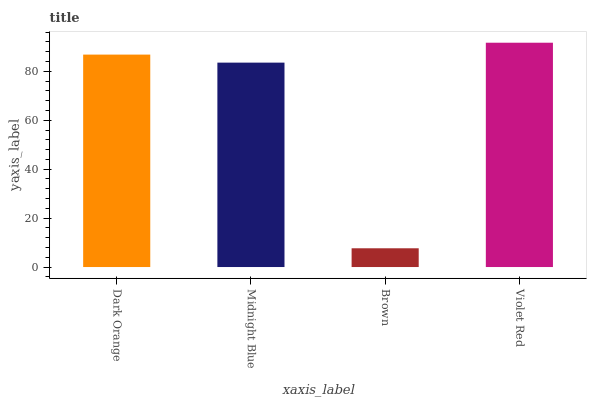Is Brown the minimum?
Answer yes or no. Yes. Is Violet Red the maximum?
Answer yes or no. Yes. Is Midnight Blue the minimum?
Answer yes or no. No. Is Midnight Blue the maximum?
Answer yes or no. No. Is Dark Orange greater than Midnight Blue?
Answer yes or no. Yes. Is Midnight Blue less than Dark Orange?
Answer yes or no. Yes. Is Midnight Blue greater than Dark Orange?
Answer yes or no. No. Is Dark Orange less than Midnight Blue?
Answer yes or no. No. Is Dark Orange the high median?
Answer yes or no. Yes. Is Midnight Blue the low median?
Answer yes or no. Yes. Is Brown the high median?
Answer yes or no. No. Is Brown the low median?
Answer yes or no. No. 